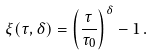<formula> <loc_0><loc_0><loc_500><loc_500>\xi ( \tau , \delta ) = \left ( \frac { \tau } { \tau _ { 0 } } \right ) ^ { \delta } - 1 \, .</formula> 